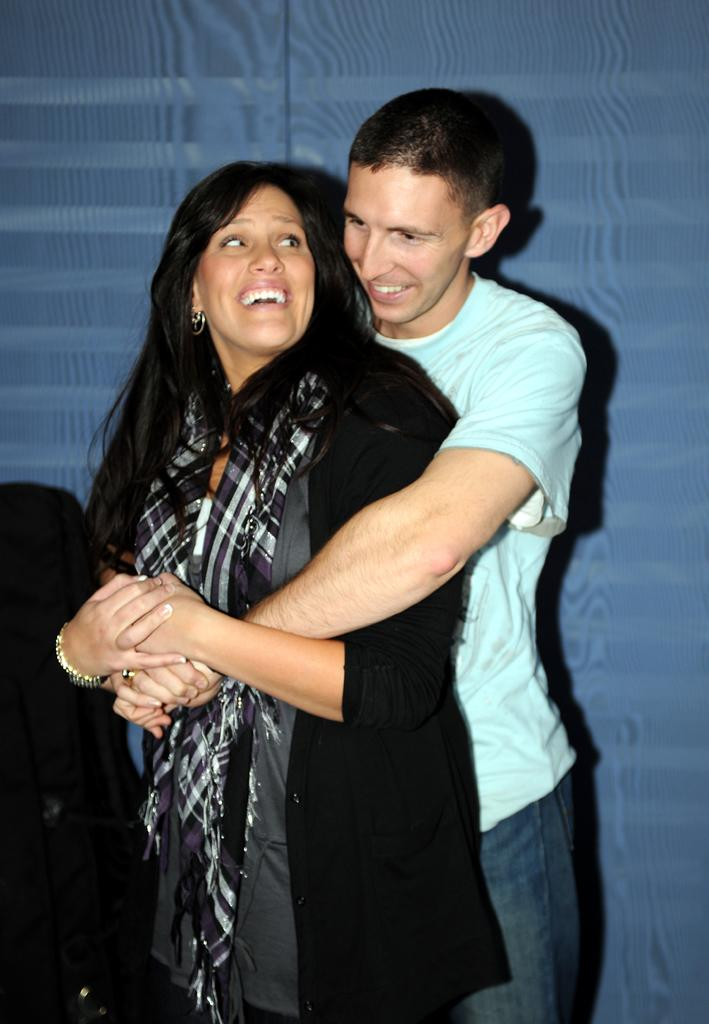How many people are present in the image? There are two people in the image, a man and a woman. What are the people in the image doing? Both the man and the woman are standing and smiling. What can be seen in the background of the image? There is a wall in the background of the image. What type of robin can be seen perched on the woman's shoulder in the image? There is no robin present in the image; it only features a man and a woman standing and smiling. 